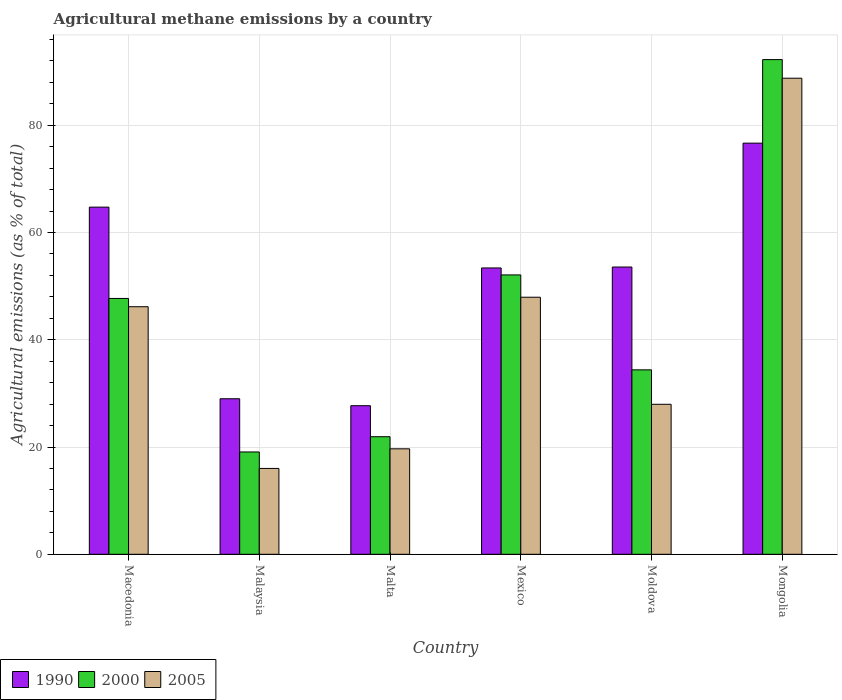Are the number of bars per tick equal to the number of legend labels?
Give a very brief answer. Yes. Are the number of bars on each tick of the X-axis equal?
Keep it short and to the point. Yes. What is the label of the 5th group of bars from the left?
Provide a succinct answer. Moldova. In how many cases, is the number of bars for a given country not equal to the number of legend labels?
Make the answer very short. 0. What is the amount of agricultural methane emitted in 2005 in Malta?
Ensure brevity in your answer.  19.67. Across all countries, what is the maximum amount of agricultural methane emitted in 1990?
Ensure brevity in your answer.  76.66. Across all countries, what is the minimum amount of agricultural methane emitted in 2005?
Your answer should be very brief. 16.01. In which country was the amount of agricultural methane emitted in 2005 maximum?
Make the answer very short. Mongolia. In which country was the amount of agricultural methane emitted in 2005 minimum?
Provide a short and direct response. Malaysia. What is the total amount of agricultural methane emitted in 2000 in the graph?
Give a very brief answer. 267.43. What is the difference between the amount of agricultural methane emitted in 2005 in Malta and that in Mongolia?
Make the answer very short. -69.1. What is the difference between the amount of agricultural methane emitted in 1990 in Malta and the amount of agricultural methane emitted in 2000 in Moldova?
Provide a short and direct response. -6.68. What is the average amount of agricultural methane emitted in 1990 per country?
Your answer should be compact. 50.84. What is the difference between the amount of agricultural methane emitted of/in 2005 and amount of agricultural methane emitted of/in 2000 in Moldova?
Give a very brief answer. -6.42. In how many countries, is the amount of agricultural methane emitted in 2005 greater than 20 %?
Provide a short and direct response. 4. What is the ratio of the amount of agricultural methane emitted in 2000 in Malaysia to that in Mexico?
Offer a very short reply. 0.37. What is the difference between the highest and the second highest amount of agricultural methane emitted in 2005?
Offer a very short reply. 42.61. What is the difference between the highest and the lowest amount of agricultural methane emitted in 2000?
Your answer should be very brief. 73.16. In how many countries, is the amount of agricultural methane emitted in 2005 greater than the average amount of agricultural methane emitted in 2005 taken over all countries?
Offer a very short reply. 3. Is the sum of the amount of agricultural methane emitted in 2005 in Malaysia and Moldova greater than the maximum amount of agricultural methane emitted in 2000 across all countries?
Provide a short and direct response. No. What does the 1st bar from the left in Malta represents?
Provide a succinct answer. 1990. What does the 1st bar from the right in Mongolia represents?
Make the answer very short. 2005. How many bars are there?
Your answer should be very brief. 18. Are all the bars in the graph horizontal?
Offer a terse response. No. Does the graph contain any zero values?
Your answer should be very brief. No. Does the graph contain grids?
Offer a terse response. Yes. Where does the legend appear in the graph?
Your answer should be compact. Bottom left. How many legend labels are there?
Provide a short and direct response. 3. What is the title of the graph?
Your answer should be compact. Agricultural methane emissions by a country. Does "2011" appear as one of the legend labels in the graph?
Provide a short and direct response. No. What is the label or title of the X-axis?
Keep it short and to the point. Country. What is the label or title of the Y-axis?
Your answer should be compact. Agricultural emissions (as % of total). What is the Agricultural emissions (as % of total) in 1990 in Macedonia?
Keep it short and to the point. 64.73. What is the Agricultural emissions (as % of total) in 2000 in Macedonia?
Your answer should be very brief. 47.7. What is the Agricultural emissions (as % of total) of 2005 in Macedonia?
Provide a short and direct response. 46.16. What is the Agricultural emissions (as % of total) in 1990 in Malaysia?
Offer a terse response. 29. What is the Agricultural emissions (as % of total) of 2000 in Malaysia?
Keep it short and to the point. 19.08. What is the Agricultural emissions (as % of total) in 2005 in Malaysia?
Offer a very short reply. 16.01. What is the Agricultural emissions (as % of total) in 1990 in Malta?
Offer a terse response. 27.71. What is the Agricultural emissions (as % of total) in 2000 in Malta?
Your answer should be compact. 21.92. What is the Agricultural emissions (as % of total) in 2005 in Malta?
Ensure brevity in your answer.  19.67. What is the Agricultural emissions (as % of total) of 1990 in Mexico?
Your answer should be compact. 53.39. What is the Agricultural emissions (as % of total) of 2000 in Mexico?
Ensure brevity in your answer.  52.09. What is the Agricultural emissions (as % of total) in 2005 in Mexico?
Provide a succinct answer. 47.93. What is the Agricultural emissions (as % of total) of 1990 in Moldova?
Provide a short and direct response. 53.56. What is the Agricultural emissions (as % of total) of 2000 in Moldova?
Ensure brevity in your answer.  34.39. What is the Agricultural emissions (as % of total) in 2005 in Moldova?
Keep it short and to the point. 27.97. What is the Agricultural emissions (as % of total) in 1990 in Mongolia?
Offer a very short reply. 76.66. What is the Agricultural emissions (as % of total) in 2000 in Mongolia?
Offer a very short reply. 92.24. What is the Agricultural emissions (as % of total) of 2005 in Mongolia?
Ensure brevity in your answer.  88.77. Across all countries, what is the maximum Agricultural emissions (as % of total) of 1990?
Your answer should be compact. 76.66. Across all countries, what is the maximum Agricultural emissions (as % of total) in 2000?
Your response must be concise. 92.24. Across all countries, what is the maximum Agricultural emissions (as % of total) of 2005?
Keep it short and to the point. 88.77. Across all countries, what is the minimum Agricultural emissions (as % of total) in 1990?
Provide a succinct answer. 27.71. Across all countries, what is the minimum Agricultural emissions (as % of total) of 2000?
Offer a very short reply. 19.08. Across all countries, what is the minimum Agricultural emissions (as % of total) of 2005?
Offer a terse response. 16.01. What is the total Agricultural emissions (as % of total) in 1990 in the graph?
Ensure brevity in your answer.  305.05. What is the total Agricultural emissions (as % of total) in 2000 in the graph?
Offer a terse response. 267.43. What is the total Agricultural emissions (as % of total) of 2005 in the graph?
Keep it short and to the point. 246.51. What is the difference between the Agricultural emissions (as % of total) of 1990 in Macedonia and that in Malaysia?
Your answer should be very brief. 35.73. What is the difference between the Agricultural emissions (as % of total) of 2000 in Macedonia and that in Malaysia?
Your answer should be compact. 28.63. What is the difference between the Agricultural emissions (as % of total) in 2005 in Macedonia and that in Malaysia?
Offer a very short reply. 30.15. What is the difference between the Agricultural emissions (as % of total) in 1990 in Macedonia and that in Malta?
Provide a succinct answer. 37.02. What is the difference between the Agricultural emissions (as % of total) of 2000 in Macedonia and that in Malta?
Your answer should be compact. 25.78. What is the difference between the Agricultural emissions (as % of total) of 2005 in Macedonia and that in Malta?
Your answer should be very brief. 26.49. What is the difference between the Agricultural emissions (as % of total) in 1990 in Macedonia and that in Mexico?
Your answer should be compact. 11.34. What is the difference between the Agricultural emissions (as % of total) in 2000 in Macedonia and that in Mexico?
Your answer should be very brief. -4.39. What is the difference between the Agricultural emissions (as % of total) in 2005 in Macedonia and that in Mexico?
Your answer should be very brief. -1.77. What is the difference between the Agricultural emissions (as % of total) in 1990 in Macedonia and that in Moldova?
Provide a succinct answer. 11.17. What is the difference between the Agricultural emissions (as % of total) in 2000 in Macedonia and that in Moldova?
Your answer should be very brief. 13.31. What is the difference between the Agricultural emissions (as % of total) in 2005 in Macedonia and that in Moldova?
Keep it short and to the point. 18.19. What is the difference between the Agricultural emissions (as % of total) in 1990 in Macedonia and that in Mongolia?
Give a very brief answer. -11.93. What is the difference between the Agricultural emissions (as % of total) of 2000 in Macedonia and that in Mongolia?
Offer a terse response. -44.53. What is the difference between the Agricultural emissions (as % of total) in 2005 in Macedonia and that in Mongolia?
Make the answer very short. -42.61. What is the difference between the Agricultural emissions (as % of total) in 1990 in Malaysia and that in Malta?
Give a very brief answer. 1.29. What is the difference between the Agricultural emissions (as % of total) of 2000 in Malaysia and that in Malta?
Make the answer very short. -2.84. What is the difference between the Agricultural emissions (as % of total) of 2005 in Malaysia and that in Malta?
Provide a short and direct response. -3.65. What is the difference between the Agricultural emissions (as % of total) in 1990 in Malaysia and that in Mexico?
Give a very brief answer. -24.39. What is the difference between the Agricultural emissions (as % of total) of 2000 in Malaysia and that in Mexico?
Make the answer very short. -33.01. What is the difference between the Agricultural emissions (as % of total) in 2005 in Malaysia and that in Mexico?
Provide a succinct answer. -31.92. What is the difference between the Agricultural emissions (as % of total) of 1990 in Malaysia and that in Moldova?
Your response must be concise. -24.56. What is the difference between the Agricultural emissions (as % of total) in 2000 in Malaysia and that in Moldova?
Offer a very short reply. -15.31. What is the difference between the Agricultural emissions (as % of total) of 2005 in Malaysia and that in Moldova?
Keep it short and to the point. -11.96. What is the difference between the Agricultural emissions (as % of total) of 1990 in Malaysia and that in Mongolia?
Ensure brevity in your answer.  -47.66. What is the difference between the Agricultural emissions (as % of total) in 2000 in Malaysia and that in Mongolia?
Give a very brief answer. -73.16. What is the difference between the Agricultural emissions (as % of total) of 2005 in Malaysia and that in Mongolia?
Give a very brief answer. -72.76. What is the difference between the Agricultural emissions (as % of total) in 1990 in Malta and that in Mexico?
Make the answer very short. -25.68. What is the difference between the Agricultural emissions (as % of total) of 2000 in Malta and that in Mexico?
Provide a short and direct response. -30.17. What is the difference between the Agricultural emissions (as % of total) in 2005 in Malta and that in Mexico?
Offer a terse response. -28.27. What is the difference between the Agricultural emissions (as % of total) of 1990 in Malta and that in Moldova?
Your answer should be compact. -25.85. What is the difference between the Agricultural emissions (as % of total) of 2000 in Malta and that in Moldova?
Give a very brief answer. -12.47. What is the difference between the Agricultural emissions (as % of total) in 2005 in Malta and that in Moldova?
Give a very brief answer. -8.3. What is the difference between the Agricultural emissions (as % of total) in 1990 in Malta and that in Mongolia?
Ensure brevity in your answer.  -48.95. What is the difference between the Agricultural emissions (as % of total) of 2000 in Malta and that in Mongolia?
Offer a terse response. -70.31. What is the difference between the Agricultural emissions (as % of total) of 2005 in Malta and that in Mongolia?
Provide a short and direct response. -69.1. What is the difference between the Agricultural emissions (as % of total) in 1990 in Mexico and that in Moldova?
Provide a succinct answer. -0.17. What is the difference between the Agricultural emissions (as % of total) of 2000 in Mexico and that in Moldova?
Keep it short and to the point. 17.7. What is the difference between the Agricultural emissions (as % of total) in 2005 in Mexico and that in Moldova?
Make the answer very short. 19.96. What is the difference between the Agricultural emissions (as % of total) of 1990 in Mexico and that in Mongolia?
Your response must be concise. -23.27. What is the difference between the Agricultural emissions (as % of total) in 2000 in Mexico and that in Mongolia?
Make the answer very short. -40.15. What is the difference between the Agricultural emissions (as % of total) of 2005 in Mexico and that in Mongolia?
Offer a terse response. -40.84. What is the difference between the Agricultural emissions (as % of total) of 1990 in Moldova and that in Mongolia?
Give a very brief answer. -23.1. What is the difference between the Agricultural emissions (as % of total) of 2000 in Moldova and that in Mongolia?
Keep it short and to the point. -57.85. What is the difference between the Agricultural emissions (as % of total) of 2005 in Moldova and that in Mongolia?
Provide a short and direct response. -60.8. What is the difference between the Agricultural emissions (as % of total) of 1990 in Macedonia and the Agricultural emissions (as % of total) of 2000 in Malaysia?
Offer a terse response. 45.65. What is the difference between the Agricultural emissions (as % of total) in 1990 in Macedonia and the Agricultural emissions (as % of total) in 2005 in Malaysia?
Give a very brief answer. 48.72. What is the difference between the Agricultural emissions (as % of total) in 2000 in Macedonia and the Agricultural emissions (as % of total) in 2005 in Malaysia?
Offer a very short reply. 31.69. What is the difference between the Agricultural emissions (as % of total) of 1990 in Macedonia and the Agricultural emissions (as % of total) of 2000 in Malta?
Ensure brevity in your answer.  42.81. What is the difference between the Agricultural emissions (as % of total) in 1990 in Macedonia and the Agricultural emissions (as % of total) in 2005 in Malta?
Provide a short and direct response. 45.06. What is the difference between the Agricultural emissions (as % of total) of 2000 in Macedonia and the Agricultural emissions (as % of total) of 2005 in Malta?
Offer a terse response. 28.04. What is the difference between the Agricultural emissions (as % of total) in 1990 in Macedonia and the Agricultural emissions (as % of total) in 2000 in Mexico?
Keep it short and to the point. 12.64. What is the difference between the Agricultural emissions (as % of total) in 1990 in Macedonia and the Agricultural emissions (as % of total) in 2005 in Mexico?
Your response must be concise. 16.8. What is the difference between the Agricultural emissions (as % of total) of 2000 in Macedonia and the Agricultural emissions (as % of total) of 2005 in Mexico?
Your answer should be compact. -0.23. What is the difference between the Agricultural emissions (as % of total) of 1990 in Macedonia and the Agricultural emissions (as % of total) of 2000 in Moldova?
Give a very brief answer. 30.34. What is the difference between the Agricultural emissions (as % of total) of 1990 in Macedonia and the Agricultural emissions (as % of total) of 2005 in Moldova?
Your answer should be very brief. 36.76. What is the difference between the Agricultural emissions (as % of total) in 2000 in Macedonia and the Agricultural emissions (as % of total) in 2005 in Moldova?
Give a very brief answer. 19.73. What is the difference between the Agricultural emissions (as % of total) of 1990 in Macedonia and the Agricultural emissions (as % of total) of 2000 in Mongolia?
Offer a very short reply. -27.51. What is the difference between the Agricultural emissions (as % of total) in 1990 in Macedonia and the Agricultural emissions (as % of total) in 2005 in Mongolia?
Provide a succinct answer. -24.04. What is the difference between the Agricultural emissions (as % of total) of 2000 in Macedonia and the Agricultural emissions (as % of total) of 2005 in Mongolia?
Give a very brief answer. -41.06. What is the difference between the Agricultural emissions (as % of total) in 1990 in Malaysia and the Agricultural emissions (as % of total) in 2000 in Malta?
Your response must be concise. 7.08. What is the difference between the Agricultural emissions (as % of total) in 1990 in Malaysia and the Agricultural emissions (as % of total) in 2005 in Malta?
Ensure brevity in your answer.  9.34. What is the difference between the Agricultural emissions (as % of total) of 2000 in Malaysia and the Agricultural emissions (as % of total) of 2005 in Malta?
Keep it short and to the point. -0.59. What is the difference between the Agricultural emissions (as % of total) in 1990 in Malaysia and the Agricultural emissions (as % of total) in 2000 in Mexico?
Your response must be concise. -23.09. What is the difference between the Agricultural emissions (as % of total) in 1990 in Malaysia and the Agricultural emissions (as % of total) in 2005 in Mexico?
Give a very brief answer. -18.93. What is the difference between the Agricultural emissions (as % of total) in 2000 in Malaysia and the Agricultural emissions (as % of total) in 2005 in Mexico?
Ensure brevity in your answer.  -28.85. What is the difference between the Agricultural emissions (as % of total) in 1990 in Malaysia and the Agricultural emissions (as % of total) in 2000 in Moldova?
Keep it short and to the point. -5.39. What is the difference between the Agricultural emissions (as % of total) in 1990 in Malaysia and the Agricultural emissions (as % of total) in 2005 in Moldova?
Provide a succinct answer. 1.03. What is the difference between the Agricultural emissions (as % of total) of 2000 in Malaysia and the Agricultural emissions (as % of total) of 2005 in Moldova?
Provide a short and direct response. -8.89. What is the difference between the Agricultural emissions (as % of total) of 1990 in Malaysia and the Agricultural emissions (as % of total) of 2000 in Mongolia?
Keep it short and to the point. -63.24. What is the difference between the Agricultural emissions (as % of total) of 1990 in Malaysia and the Agricultural emissions (as % of total) of 2005 in Mongolia?
Give a very brief answer. -59.77. What is the difference between the Agricultural emissions (as % of total) in 2000 in Malaysia and the Agricultural emissions (as % of total) in 2005 in Mongolia?
Offer a very short reply. -69.69. What is the difference between the Agricultural emissions (as % of total) in 1990 in Malta and the Agricultural emissions (as % of total) in 2000 in Mexico?
Keep it short and to the point. -24.38. What is the difference between the Agricultural emissions (as % of total) in 1990 in Malta and the Agricultural emissions (as % of total) in 2005 in Mexico?
Keep it short and to the point. -20.22. What is the difference between the Agricultural emissions (as % of total) of 2000 in Malta and the Agricultural emissions (as % of total) of 2005 in Mexico?
Your response must be concise. -26.01. What is the difference between the Agricultural emissions (as % of total) of 1990 in Malta and the Agricultural emissions (as % of total) of 2000 in Moldova?
Offer a very short reply. -6.68. What is the difference between the Agricultural emissions (as % of total) in 1990 in Malta and the Agricultural emissions (as % of total) in 2005 in Moldova?
Give a very brief answer. -0.26. What is the difference between the Agricultural emissions (as % of total) in 2000 in Malta and the Agricultural emissions (as % of total) in 2005 in Moldova?
Offer a very short reply. -6.05. What is the difference between the Agricultural emissions (as % of total) of 1990 in Malta and the Agricultural emissions (as % of total) of 2000 in Mongolia?
Provide a succinct answer. -64.53. What is the difference between the Agricultural emissions (as % of total) in 1990 in Malta and the Agricultural emissions (as % of total) in 2005 in Mongolia?
Ensure brevity in your answer.  -61.06. What is the difference between the Agricultural emissions (as % of total) in 2000 in Malta and the Agricultural emissions (as % of total) in 2005 in Mongolia?
Make the answer very short. -66.85. What is the difference between the Agricultural emissions (as % of total) in 1990 in Mexico and the Agricultural emissions (as % of total) in 2000 in Moldova?
Ensure brevity in your answer.  19. What is the difference between the Agricultural emissions (as % of total) in 1990 in Mexico and the Agricultural emissions (as % of total) in 2005 in Moldova?
Offer a terse response. 25.42. What is the difference between the Agricultural emissions (as % of total) in 2000 in Mexico and the Agricultural emissions (as % of total) in 2005 in Moldova?
Your answer should be compact. 24.12. What is the difference between the Agricultural emissions (as % of total) in 1990 in Mexico and the Agricultural emissions (as % of total) in 2000 in Mongolia?
Offer a terse response. -38.84. What is the difference between the Agricultural emissions (as % of total) of 1990 in Mexico and the Agricultural emissions (as % of total) of 2005 in Mongolia?
Provide a short and direct response. -35.38. What is the difference between the Agricultural emissions (as % of total) in 2000 in Mexico and the Agricultural emissions (as % of total) in 2005 in Mongolia?
Offer a very short reply. -36.68. What is the difference between the Agricultural emissions (as % of total) of 1990 in Moldova and the Agricultural emissions (as % of total) of 2000 in Mongolia?
Your answer should be compact. -38.67. What is the difference between the Agricultural emissions (as % of total) in 1990 in Moldova and the Agricultural emissions (as % of total) in 2005 in Mongolia?
Your answer should be very brief. -35.21. What is the difference between the Agricultural emissions (as % of total) in 2000 in Moldova and the Agricultural emissions (as % of total) in 2005 in Mongolia?
Your answer should be compact. -54.38. What is the average Agricultural emissions (as % of total) in 1990 per country?
Offer a very short reply. 50.84. What is the average Agricultural emissions (as % of total) in 2000 per country?
Make the answer very short. 44.57. What is the average Agricultural emissions (as % of total) of 2005 per country?
Keep it short and to the point. 41.08. What is the difference between the Agricultural emissions (as % of total) in 1990 and Agricultural emissions (as % of total) in 2000 in Macedonia?
Keep it short and to the point. 17.03. What is the difference between the Agricultural emissions (as % of total) in 1990 and Agricultural emissions (as % of total) in 2005 in Macedonia?
Your answer should be compact. 18.57. What is the difference between the Agricultural emissions (as % of total) in 2000 and Agricultural emissions (as % of total) in 2005 in Macedonia?
Make the answer very short. 1.55. What is the difference between the Agricultural emissions (as % of total) of 1990 and Agricultural emissions (as % of total) of 2000 in Malaysia?
Your answer should be compact. 9.92. What is the difference between the Agricultural emissions (as % of total) of 1990 and Agricultural emissions (as % of total) of 2005 in Malaysia?
Make the answer very short. 12.99. What is the difference between the Agricultural emissions (as % of total) in 2000 and Agricultural emissions (as % of total) in 2005 in Malaysia?
Keep it short and to the point. 3.07. What is the difference between the Agricultural emissions (as % of total) of 1990 and Agricultural emissions (as % of total) of 2000 in Malta?
Provide a short and direct response. 5.78. What is the difference between the Agricultural emissions (as % of total) of 1990 and Agricultural emissions (as % of total) of 2005 in Malta?
Make the answer very short. 8.04. What is the difference between the Agricultural emissions (as % of total) of 2000 and Agricultural emissions (as % of total) of 2005 in Malta?
Ensure brevity in your answer.  2.26. What is the difference between the Agricultural emissions (as % of total) of 1990 and Agricultural emissions (as % of total) of 2000 in Mexico?
Your response must be concise. 1.3. What is the difference between the Agricultural emissions (as % of total) in 1990 and Agricultural emissions (as % of total) in 2005 in Mexico?
Your response must be concise. 5.46. What is the difference between the Agricultural emissions (as % of total) in 2000 and Agricultural emissions (as % of total) in 2005 in Mexico?
Make the answer very short. 4.16. What is the difference between the Agricultural emissions (as % of total) in 1990 and Agricultural emissions (as % of total) in 2000 in Moldova?
Keep it short and to the point. 19.17. What is the difference between the Agricultural emissions (as % of total) in 1990 and Agricultural emissions (as % of total) in 2005 in Moldova?
Your response must be concise. 25.59. What is the difference between the Agricultural emissions (as % of total) in 2000 and Agricultural emissions (as % of total) in 2005 in Moldova?
Provide a short and direct response. 6.42. What is the difference between the Agricultural emissions (as % of total) of 1990 and Agricultural emissions (as % of total) of 2000 in Mongolia?
Your answer should be compact. -15.58. What is the difference between the Agricultural emissions (as % of total) of 1990 and Agricultural emissions (as % of total) of 2005 in Mongolia?
Your answer should be compact. -12.11. What is the difference between the Agricultural emissions (as % of total) of 2000 and Agricultural emissions (as % of total) of 2005 in Mongolia?
Your answer should be very brief. 3.47. What is the ratio of the Agricultural emissions (as % of total) in 1990 in Macedonia to that in Malaysia?
Make the answer very short. 2.23. What is the ratio of the Agricultural emissions (as % of total) of 2000 in Macedonia to that in Malaysia?
Offer a very short reply. 2.5. What is the ratio of the Agricultural emissions (as % of total) in 2005 in Macedonia to that in Malaysia?
Offer a terse response. 2.88. What is the ratio of the Agricultural emissions (as % of total) of 1990 in Macedonia to that in Malta?
Your answer should be compact. 2.34. What is the ratio of the Agricultural emissions (as % of total) of 2000 in Macedonia to that in Malta?
Make the answer very short. 2.18. What is the ratio of the Agricultural emissions (as % of total) in 2005 in Macedonia to that in Malta?
Your response must be concise. 2.35. What is the ratio of the Agricultural emissions (as % of total) in 1990 in Macedonia to that in Mexico?
Keep it short and to the point. 1.21. What is the ratio of the Agricultural emissions (as % of total) of 2000 in Macedonia to that in Mexico?
Make the answer very short. 0.92. What is the ratio of the Agricultural emissions (as % of total) of 1990 in Macedonia to that in Moldova?
Make the answer very short. 1.21. What is the ratio of the Agricultural emissions (as % of total) of 2000 in Macedonia to that in Moldova?
Your answer should be very brief. 1.39. What is the ratio of the Agricultural emissions (as % of total) of 2005 in Macedonia to that in Moldova?
Make the answer very short. 1.65. What is the ratio of the Agricultural emissions (as % of total) in 1990 in Macedonia to that in Mongolia?
Offer a very short reply. 0.84. What is the ratio of the Agricultural emissions (as % of total) in 2000 in Macedonia to that in Mongolia?
Your answer should be compact. 0.52. What is the ratio of the Agricultural emissions (as % of total) in 2005 in Macedonia to that in Mongolia?
Provide a short and direct response. 0.52. What is the ratio of the Agricultural emissions (as % of total) of 1990 in Malaysia to that in Malta?
Give a very brief answer. 1.05. What is the ratio of the Agricultural emissions (as % of total) in 2000 in Malaysia to that in Malta?
Make the answer very short. 0.87. What is the ratio of the Agricultural emissions (as % of total) of 2005 in Malaysia to that in Malta?
Make the answer very short. 0.81. What is the ratio of the Agricultural emissions (as % of total) of 1990 in Malaysia to that in Mexico?
Offer a terse response. 0.54. What is the ratio of the Agricultural emissions (as % of total) in 2000 in Malaysia to that in Mexico?
Your response must be concise. 0.37. What is the ratio of the Agricultural emissions (as % of total) in 2005 in Malaysia to that in Mexico?
Offer a very short reply. 0.33. What is the ratio of the Agricultural emissions (as % of total) in 1990 in Malaysia to that in Moldova?
Your answer should be very brief. 0.54. What is the ratio of the Agricultural emissions (as % of total) of 2000 in Malaysia to that in Moldova?
Keep it short and to the point. 0.55. What is the ratio of the Agricultural emissions (as % of total) in 2005 in Malaysia to that in Moldova?
Give a very brief answer. 0.57. What is the ratio of the Agricultural emissions (as % of total) in 1990 in Malaysia to that in Mongolia?
Keep it short and to the point. 0.38. What is the ratio of the Agricultural emissions (as % of total) in 2000 in Malaysia to that in Mongolia?
Provide a short and direct response. 0.21. What is the ratio of the Agricultural emissions (as % of total) in 2005 in Malaysia to that in Mongolia?
Offer a very short reply. 0.18. What is the ratio of the Agricultural emissions (as % of total) in 1990 in Malta to that in Mexico?
Your answer should be very brief. 0.52. What is the ratio of the Agricultural emissions (as % of total) in 2000 in Malta to that in Mexico?
Make the answer very short. 0.42. What is the ratio of the Agricultural emissions (as % of total) in 2005 in Malta to that in Mexico?
Your answer should be very brief. 0.41. What is the ratio of the Agricultural emissions (as % of total) of 1990 in Malta to that in Moldova?
Offer a terse response. 0.52. What is the ratio of the Agricultural emissions (as % of total) in 2000 in Malta to that in Moldova?
Provide a succinct answer. 0.64. What is the ratio of the Agricultural emissions (as % of total) in 2005 in Malta to that in Moldova?
Ensure brevity in your answer.  0.7. What is the ratio of the Agricultural emissions (as % of total) of 1990 in Malta to that in Mongolia?
Your response must be concise. 0.36. What is the ratio of the Agricultural emissions (as % of total) in 2000 in Malta to that in Mongolia?
Your answer should be compact. 0.24. What is the ratio of the Agricultural emissions (as % of total) of 2005 in Malta to that in Mongolia?
Provide a succinct answer. 0.22. What is the ratio of the Agricultural emissions (as % of total) in 2000 in Mexico to that in Moldova?
Make the answer very short. 1.51. What is the ratio of the Agricultural emissions (as % of total) in 2005 in Mexico to that in Moldova?
Provide a short and direct response. 1.71. What is the ratio of the Agricultural emissions (as % of total) of 1990 in Mexico to that in Mongolia?
Make the answer very short. 0.7. What is the ratio of the Agricultural emissions (as % of total) of 2000 in Mexico to that in Mongolia?
Your answer should be very brief. 0.56. What is the ratio of the Agricultural emissions (as % of total) of 2005 in Mexico to that in Mongolia?
Offer a very short reply. 0.54. What is the ratio of the Agricultural emissions (as % of total) of 1990 in Moldova to that in Mongolia?
Make the answer very short. 0.7. What is the ratio of the Agricultural emissions (as % of total) in 2000 in Moldova to that in Mongolia?
Keep it short and to the point. 0.37. What is the ratio of the Agricultural emissions (as % of total) in 2005 in Moldova to that in Mongolia?
Keep it short and to the point. 0.32. What is the difference between the highest and the second highest Agricultural emissions (as % of total) in 1990?
Keep it short and to the point. 11.93. What is the difference between the highest and the second highest Agricultural emissions (as % of total) of 2000?
Your response must be concise. 40.15. What is the difference between the highest and the second highest Agricultural emissions (as % of total) in 2005?
Make the answer very short. 40.84. What is the difference between the highest and the lowest Agricultural emissions (as % of total) of 1990?
Provide a succinct answer. 48.95. What is the difference between the highest and the lowest Agricultural emissions (as % of total) of 2000?
Give a very brief answer. 73.16. What is the difference between the highest and the lowest Agricultural emissions (as % of total) in 2005?
Give a very brief answer. 72.76. 